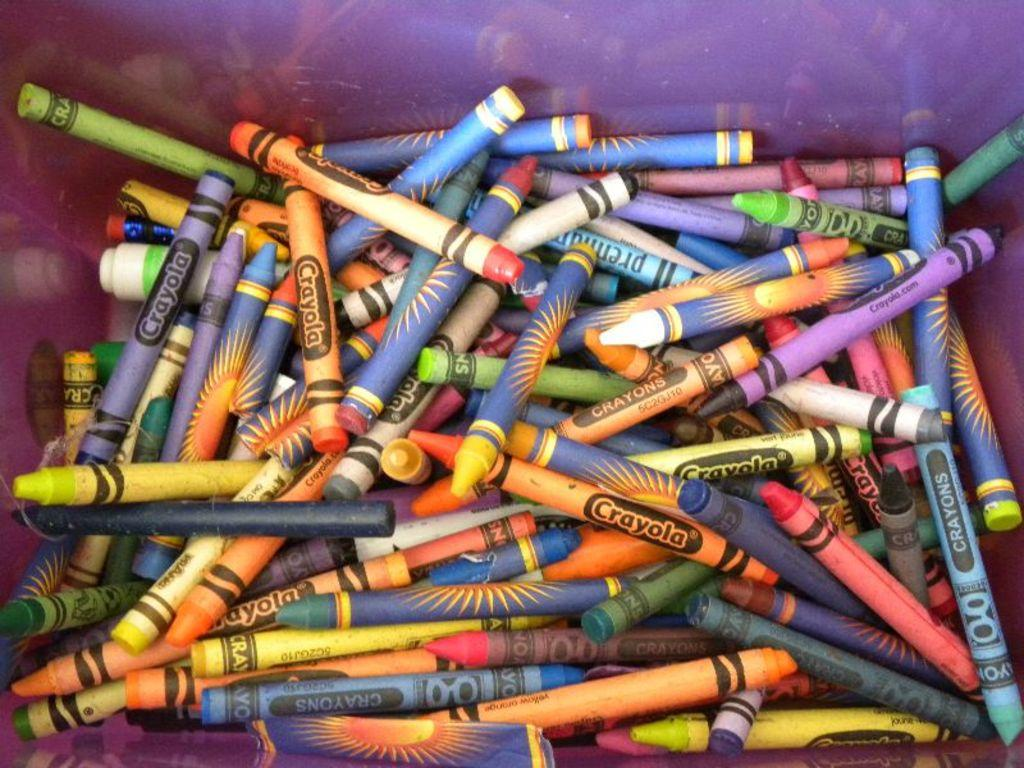<image>
Offer a succinct explanation of the picture presented. Many crayons bunched together and the word "CRAYOLA" on the sides. 